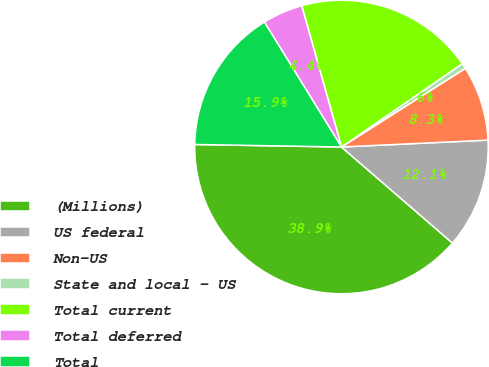Convert chart to OTSL. <chart><loc_0><loc_0><loc_500><loc_500><pie_chart><fcel>(Millions)<fcel>US federal<fcel>Non-US<fcel>State and local - US<fcel>Total current<fcel>Total deferred<fcel>Total<nl><fcel>38.92%<fcel>12.1%<fcel>8.26%<fcel>0.6%<fcel>19.76%<fcel>4.43%<fcel>15.93%<nl></chart> 